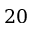Convert formula to latex. <formula><loc_0><loc_0><loc_500><loc_500>2 0</formula> 